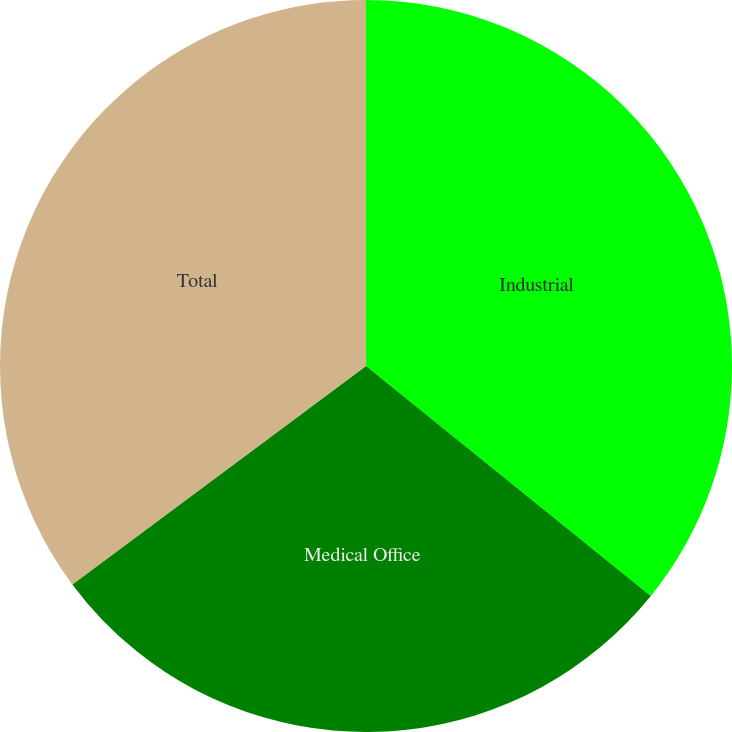Convert chart. <chart><loc_0><loc_0><loc_500><loc_500><pie_chart><fcel>Industrial<fcel>Medical Office<fcel>Total<nl><fcel>35.81%<fcel>29.01%<fcel>35.18%<nl></chart> 